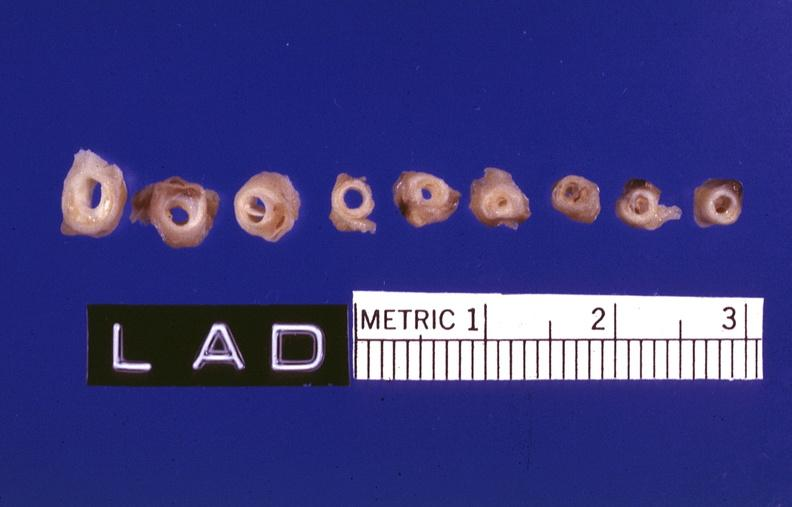what left anterior descending coronary artery?
Answer the question using a single word or phrase. Atherosclerosis 